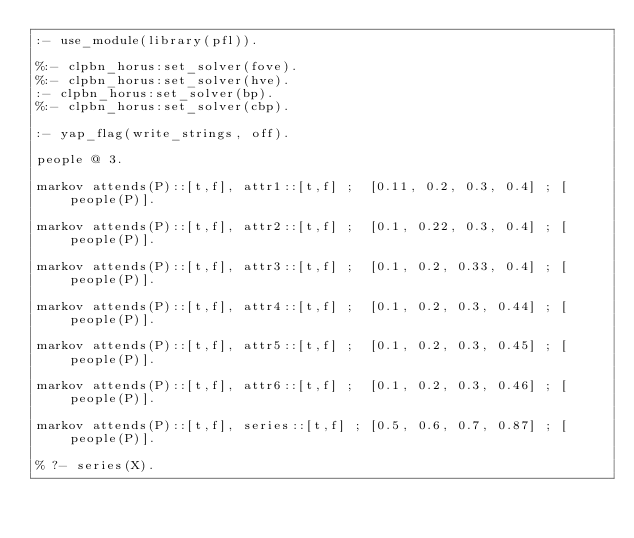<code> <loc_0><loc_0><loc_500><loc_500><_Prolog_>:- use_module(library(pfl)).

%:- clpbn_horus:set_solver(fove).
%:- clpbn_horus:set_solver(hve).
:- clpbn_horus:set_solver(bp).
%:- clpbn_horus:set_solver(cbp).

:- yap_flag(write_strings, off).

people @ 3.

markov attends(P)::[t,f], attr1::[t,f] ;  [0.11, 0.2, 0.3, 0.4] ; [people(P)].

markov attends(P)::[t,f], attr2::[t,f] ;  [0.1, 0.22, 0.3, 0.4] ; [people(P)].

markov attends(P)::[t,f], attr3::[t,f] ;  [0.1, 0.2, 0.33, 0.4] ; [people(P)].

markov attends(P)::[t,f], attr4::[t,f] ;  [0.1, 0.2, 0.3, 0.44] ; [people(P)].

markov attends(P)::[t,f], attr5::[t,f] ;  [0.1, 0.2, 0.3, 0.45] ; [people(P)].

markov attends(P)::[t,f], attr6::[t,f] ;  [0.1, 0.2, 0.3, 0.46] ; [people(P)].

markov attends(P)::[t,f], series::[t,f] ; [0.5, 0.6, 0.7, 0.87] ; [people(P)].

% ?- series(X).

</code> 